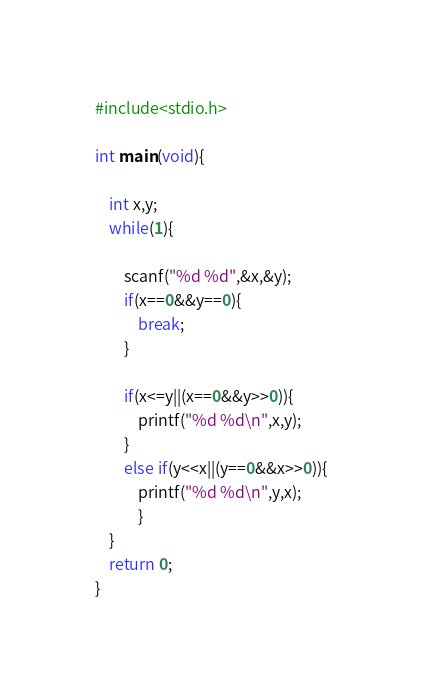Convert code to text. <code><loc_0><loc_0><loc_500><loc_500><_C_>#include<stdio.h>

int main(void){

	int x,y;
	while(1){
 
 		scanf("%d %d",&x,&y);
		if(x==0&&y==0){
			break;
		}

		if(x<=y||(x==0&&y>>0)){
			printf("%d %d\n",x,y);
		}
		else if(y<<x||(y==0&&x>>0)){
			printf("%d %d\n",y,x);
	        }
 	}
	return 0;
}

</code> 